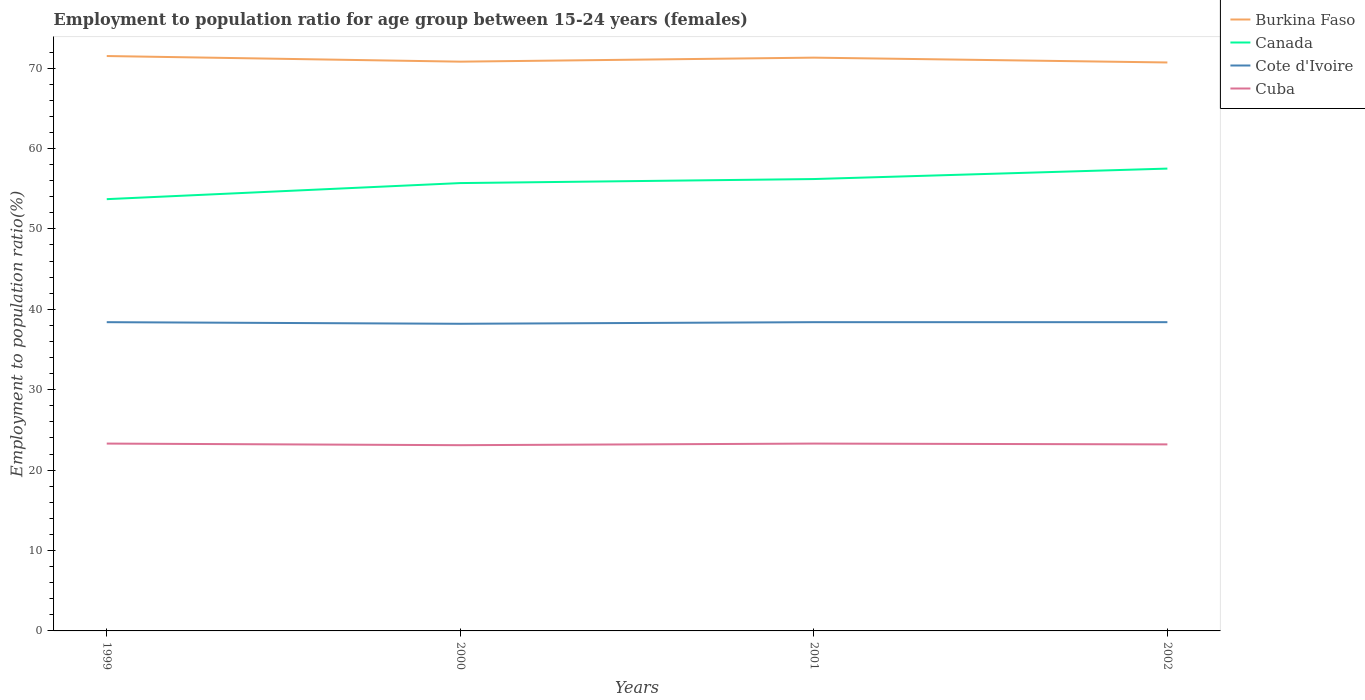How many different coloured lines are there?
Your response must be concise. 4. Does the line corresponding to Cuba intersect with the line corresponding to Cote d'Ivoire?
Your answer should be very brief. No. Across all years, what is the maximum employment to population ratio in Cote d'Ivoire?
Ensure brevity in your answer.  38.2. What is the total employment to population ratio in Burkina Faso in the graph?
Give a very brief answer. 0.8. What is the difference between the highest and the second highest employment to population ratio in Cote d'Ivoire?
Your answer should be very brief. 0.2. What is the difference between the highest and the lowest employment to population ratio in Canada?
Provide a short and direct response. 2. How many years are there in the graph?
Make the answer very short. 4. Does the graph contain any zero values?
Make the answer very short. No. Does the graph contain grids?
Your answer should be very brief. No. How many legend labels are there?
Make the answer very short. 4. What is the title of the graph?
Give a very brief answer. Employment to population ratio for age group between 15-24 years (females). What is the label or title of the Y-axis?
Give a very brief answer. Employment to population ratio(%). What is the Employment to population ratio(%) of Burkina Faso in 1999?
Offer a very short reply. 71.5. What is the Employment to population ratio(%) of Canada in 1999?
Keep it short and to the point. 53.7. What is the Employment to population ratio(%) in Cote d'Ivoire in 1999?
Make the answer very short. 38.4. What is the Employment to population ratio(%) in Cuba in 1999?
Give a very brief answer. 23.3. What is the Employment to population ratio(%) of Burkina Faso in 2000?
Ensure brevity in your answer.  70.8. What is the Employment to population ratio(%) in Canada in 2000?
Offer a terse response. 55.7. What is the Employment to population ratio(%) in Cote d'Ivoire in 2000?
Your response must be concise. 38.2. What is the Employment to population ratio(%) of Cuba in 2000?
Your answer should be compact. 23.1. What is the Employment to population ratio(%) of Burkina Faso in 2001?
Make the answer very short. 71.3. What is the Employment to population ratio(%) in Canada in 2001?
Make the answer very short. 56.2. What is the Employment to population ratio(%) in Cote d'Ivoire in 2001?
Your response must be concise. 38.4. What is the Employment to population ratio(%) of Cuba in 2001?
Offer a terse response. 23.3. What is the Employment to population ratio(%) of Burkina Faso in 2002?
Your response must be concise. 70.7. What is the Employment to population ratio(%) in Canada in 2002?
Provide a succinct answer. 57.5. What is the Employment to population ratio(%) of Cote d'Ivoire in 2002?
Provide a short and direct response. 38.4. What is the Employment to population ratio(%) of Cuba in 2002?
Offer a terse response. 23.2. Across all years, what is the maximum Employment to population ratio(%) in Burkina Faso?
Keep it short and to the point. 71.5. Across all years, what is the maximum Employment to population ratio(%) of Canada?
Keep it short and to the point. 57.5. Across all years, what is the maximum Employment to population ratio(%) in Cote d'Ivoire?
Give a very brief answer. 38.4. Across all years, what is the maximum Employment to population ratio(%) in Cuba?
Offer a terse response. 23.3. Across all years, what is the minimum Employment to population ratio(%) of Burkina Faso?
Give a very brief answer. 70.7. Across all years, what is the minimum Employment to population ratio(%) of Canada?
Provide a succinct answer. 53.7. Across all years, what is the minimum Employment to population ratio(%) in Cote d'Ivoire?
Provide a short and direct response. 38.2. Across all years, what is the minimum Employment to population ratio(%) in Cuba?
Make the answer very short. 23.1. What is the total Employment to population ratio(%) of Burkina Faso in the graph?
Keep it short and to the point. 284.3. What is the total Employment to population ratio(%) in Canada in the graph?
Offer a terse response. 223.1. What is the total Employment to population ratio(%) in Cote d'Ivoire in the graph?
Your response must be concise. 153.4. What is the total Employment to population ratio(%) in Cuba in the graph?
Your response must be concise. 92.9. What is the difference between the Employment to population ratio(%) of Burkina Faso in 1999 and that in 2002?
Provide a succinct answer. 0.8. What is the difference between the Employment to population ratio(%) of Canada in 1999 and that in 2002?
Keep it short and to the point. -3.8. What is the difference between the Employment to population ratio(%) of Cote d'Ivoire in 1999 and that in 2002?
Your answer should be very brief. 0. What is the difference between the Employment to population ratio(%) in Cuba in 1999 and that in 2002?
Provide a short and direct response. 0.1. What is the difference between the Employment to population ratio(%) of Canada in 2000 and that in 2001?
Give a very brief answer. -0.5. What is the difference between the Employment to population ratio(%) in Cote d'Ivoire in 2000 and that in 2001?
Provide a short and direct response. -0.2. What is the difference between the Employment to population ratio(%) of Burkina Faso in 2000 and that in 2002?
Your answer should be compact. 0.1. What is the difference between the Employment to population ratio(%) of Cuba in 2000 and that in 2002?
Offer a terse response. -0.1. What is the difference between the Employment to population ratio(%) in Burkina Faso in 1999 and the Employment to population ratio(%) in Cote d'Ivoire in 2000?
Offer a very short reply. 33.3. What is the difference between the Employment to population ratio(%) in Burkina Faso in 1999 and the Employment to population ratio(%) in Cuba in 2000?
Your answer should be very brief. 48.4. What is the difference between the Employment to population ratio(%) in Canada in 1999 and the Employment to population ratio(%) in Cote d'Ivoire in 2000?
Your answer should be compact. 15.5. What is the difference between the Employment to population ratio(%) in Canada in 1999 and the Employment to population ratio(%) in Cuba in 2000?
Keep it short and to the point. 30.6. What is the difference between the Employment to population ratio(%) in Burkina Faso in 1999 and the Employment to population ratio(%) in Cote d'Ivoire in 2001?
Provide a succinct answer. 33.1. What is the difference between the Employment to population ratio(%) in Burkina Faso in 1999 and the Employment to population ratio(%) in Cuba in 2001?
Give a very brief answer. 48.2. What is the difference between the Employment to population ratio(%) in Canada in 1999 and the Employment to population ratio(%) in Cote d'Ivoire in 2001?
Keep it short and to the point. 15.3. What is the difference between the Employment to population ratio(%) of Canada in 1999 and the Employment to population ratio(%) of Cuba in 2001?
Give a very brief answer. 30.4. What is the difference between the Employment to population ratio(%) in Cote d'Ivoire in 1999 and the Employment to population ratio(%) in Cuba in 2001?
Your answer should be very brief. 15.1. What is the difference between the Employment to population ratio(%) in Burkina Faso in 1999 and the Employment to population ratio(%) in Canada in 2002?
Give a very brief answer. 14. What is the difference between the Employment to population ratio(%) of Burkina Faso in 1999 and the Employment to population ratio(%) of Cote d'Ivoire in 2002?
Make the answer very short. 33.1. What is the difference between the Employment to population ratio(%) in Burkina Faso in 1999 and the Employment to population ratio(%) in Cuba in 2002?
Your response must be concise. 48.3. What is the difference between the Employment to population ratio(%) in Canada in 1999 and the Employment to population ratio(%) in Cote d'Ivoire in 2002?
Provide a succinct answer. 15.3. What is the difference between the Employment to population ratio(%) of Canada in 1999 and the Employment to population ratio(%) of Cuba in 2002?
Keep it short and to the point. 30.5. What is the difference between the Employment to population ratio(%) of Burkina Faso in 2000 and the Employment to population ratio(%) of Canada in 2001?
Your response must be concise. 14.6. What is the difference between the Employment to population ratio(%) of Burkina Faso in 2000 and the Employment to population ratio(%) of Cote d'Ivoire in 2001?
Keep it short and to the point. 32.4. What is the difference between the Employment to population ratio(%) in Burkina Faso in 2000 and the Employment to population ratio(%) in Cuba in 2001?
Your answer should be very brief. 47.5. What is the difference between the Employment to population ratio(%) of Canada in 2000 and the Employment to population ratio(%) of Cote d'Ivoire in 2001?
Provide a succinct answer. 17.3. What is the difference between the Employment to population ratio(%) in Canada in 2000 and the Employment to population ratio(%) in Cuba in 2001?
Give a very brief answer. 32.4. What is the difference between the Employment to population ratio(%) in Cote d'Ivoire in 2000 and the Employment to population ratio(%) in Cuba in 2001?
Provide a succinct answer. 14.9. What is the difference between the Employment to population ratio(%) in Burkina Faso in 2000 and the Employment to population ratio(%) in Cote d'Ivoire in 2002?
Offer a very short reply. 32.4. What is the difference between the Employment to population ratio(%) in Burkina Faso in 2000 and the Employment to population ratio(%) in Cuba in 2002?
Your response must be concise. 47.6. What is the difference between the Employment to population ratio(%) in Canada in 2000 and the Employment to population ratio(%) in Cuba in 2002?
Your answer should be compact. 32.5. What is the difference between the Employment to population ratio(%) of Burkina Faso in 2001 and the Employment to population ratio(%) of Cote d'Ivoire in 2002?
Provide a short and direct response. 32.9. What is the difference between the Employment to population ratio(%) in Burkina Faso in 2001 and the Employment to population ratio(%) in Cuba in 2002?
Offer a terse response. 48.1. What is the difference between the Employment to population ratio(%) of Canada in 2001 and the Employment to population ratio(%) of Cote d'Ivoire in 2002?
Offer a terse response. 17.8. What is the difference between the Employment to population ratio(%) of Canada in 2001 and the Employment to population ratio(%) of Cuba in 2002?
Your response must be concise. 33. What is the average Employment to population ratio(%) in Burkina Faso per year?
Your response must be concise. 71.08. What is the average Employment to population ratio(%) of Canada per year?
Provide a succinct answer. 55.77. What is the average Employment to population ratio(%) in Cote d'Ivoire per year?
Ensure brevity in your answer.  38.35. What is the average Employment to population ratio(%) in Cuba per year?
Offer a terse response. 23.23. In the year 1999, what is the difference between the Employment to population ratio(%) of Burkina Faso and Employment to population ratio(%) of Cote d'Ivoire?
Keep it short and to the point. 33.1. In the year 1999, what is the difference between the Employment to population ratio(%) of Burkina Faso and Employment to population ratio(%) of Cuba?
Make the answer very short. 48.2. In the year 1999, what is the difference between the Employment to population ratio(%) of Canada and Employment to population ratio(%) of Cote d'Ivoire?
Offer a terse response. 15.3. In the year 1999, what is the difference between the Employment to population ratio(%) of Canada and Employment to population ratio(%) of Cuba?
Provide a succinct answer. 30.4. In the year 2000, what is the difference between the Employment to population ratio(%) in Burkina Faso and Employment to population ratio(%) in Cote d'Ivoire?
Your response must be concise. 32.6. In the year 2000, what is the difference between the Employment to population ratio(%) in Burkina Faso and Employment to population ratio(%) in Cuba?
Keep it short and to the point. 47.7. In the year 2000, what is the difference between the Employment to population ratio(%) in Canada and Employment to population ratio(%) in Cote d'Ivoire?
Your response must be concise. 17.5. In the year 2000, what is the difference between the Employment to population ratio(%) in Canada and Employment to population ratio(%) in Cuba?
Provide a succinct answer. 32.6. In the year 2001, what is the difference between the Employment to population ratio(%) in Burkina Faso and Employment to population ratio(%) in Canada?
Make the answer very short. 15.1. In the year 2001, what is the difference between the Employment to population ratio(%) in Burkina Faso and Employment to population ratio(%) in Cote d'Ivoire?
Give a very brief answer. 32.9. In the year 2001, what is the difference between the Employment to population ratio(%) in Burkina Faso and Employment to population ratio(%) in Cuba?
Make the answer very short. 48. In the year 2001, what is the difference between the Employment to population ratio(%) in Canada and Employment to population ratio(%) in Cuba?
Your answer should be compact. 32.9. In the year 2001, what is the difference between the Employment to population ratio(%) in Cote d'Ivoire and Employment to population ratio(%) in Cuba?
Provide a succinct answer. 15.1. In the year 2002, what is the difference between the Employment to population ratio(%) of Burkina Faso and Employment to population ratio(%) of Cote d'Ivoire?
Make the answer very short. 32.3. In the year 2002, what is the difference between the Employment to population ratio(%) of Burkina Faso and Employment to population ratio(%) of Cuba?
Offer a very short reply. 47.5. In the year 2002, what is the difference between the Employment to population ratio(%) in Canada and Employment to population ratio(%) in Cote d'Ivoire?
Offer a very short reply. 19.1. In the year 2002, what is the difference between the Employment to population ratio(%) in Canada and Employment to population ratio(%) in Cuba?
Your response must be concise. 34.3. What is the ratio of the Employment to population ratio(%) of Burkina Faso in 1999 to that in 2000?
Provide a succinct answer. 1.01. What is the ratio of the Employment to population ratio(%) of Canada in 1999 to that in 2000?
Offer a terse response. 0.96. What is the ratio of the Employment to population ratio(%) in Cuba in 1999 to that in 2000?
Your response must be concise. 1.01. What is the ratio of the Employment to population ratio(%) of Canada in 1999 to that in 2001?
Offer a very short reply. 0.96. What is the ratio of the Employment to population ratio(%) of Cote d'Ivoire in 1999 to that in 2001?
Your response must be concise. 1. What is the ratio of the Employment to population ratio(%) of Cuba in 1999 to that in 2001?
Your answer should be very brief. 1. What is the ratio of the Employment to population ratio(%) in Burkina Faso in 1999 to that in 2002?
Make the answer very short. 1.01. What is the ratio of the Employment to population ratio(%) of Canada in 1999 to that in 2002?
Keep it short and to the point. 0.93. What is the ratio of the Employment to population ratio(%) of Cote d'Ivoire in 1999 to that in 2002?
Provide a short and direct response. 1. What is the ratio of the Employment to population ratio(%) of Burkina Faso in 2000 to that in 2001?
Provide a succinct answer. 0.99. What is the ratio of the Employment to population ratio(%) in Canada in 2000 to that in 2001?
Ensure brevity in your answer.  0.99. What is the ratio of the Employment to population ratio(%) in Cote d'Ivoire in 2000 to that in 2001?
Your response must be concise. 0.99. What is the ratio of the Employment to population ratio(%) in Cuba in 2000 to that in 2001?
Ensure brevity in your answer.  0.99. What is the ratio of the Employment to population ratio(%) in Burkina Faso in 2000 to that in 2002?
Offer a very short reply. 1. What is the ratio of the Employment to population ratio(%) in Canada in 2000 to that in 2002?
Make the answer very short. 0.97. What is the ratio of the Employment to population ratio(%) of Cuba in 2000 to that in 2002?
Make the answer very short. 1. What is the ratio of the Employment to population ratio(%) in Burkina Faso in 2001 to that in 2002?
Provide a short and direct response. 1.01. What is the ratio of the Employment to population ratio(%) of Canada in 2001 to that in 2002?
Keep it short and to the point. 0.98. What is the ratio of the Employment to population ratio(%) in Cote d'Ivoire in 2001 to that in 2002?
Keep it short and to the point. 1. What is the ratio of the Employment to population ratio(%) of Cuba in 2001 to that in 2002?
Provide a short and direct response. 1. What is the difference between the highest and the second highest Employment to population ratio(%) in Canada?
Give a very brief answer. 1.3. What is the difference between the highest and the second highest Employment to population ratio(%) of Cuba?
Your answer should be compact. 0. What is the difference between the highest and the lowest Employment to population ratio(%) in Burkina Faso?
Your answer should be compact. 0.8. What is the difference between the highest and the lowest Employment to population ratio(%) in Cuba?
Ensure brevity in your answer.  0.2. 